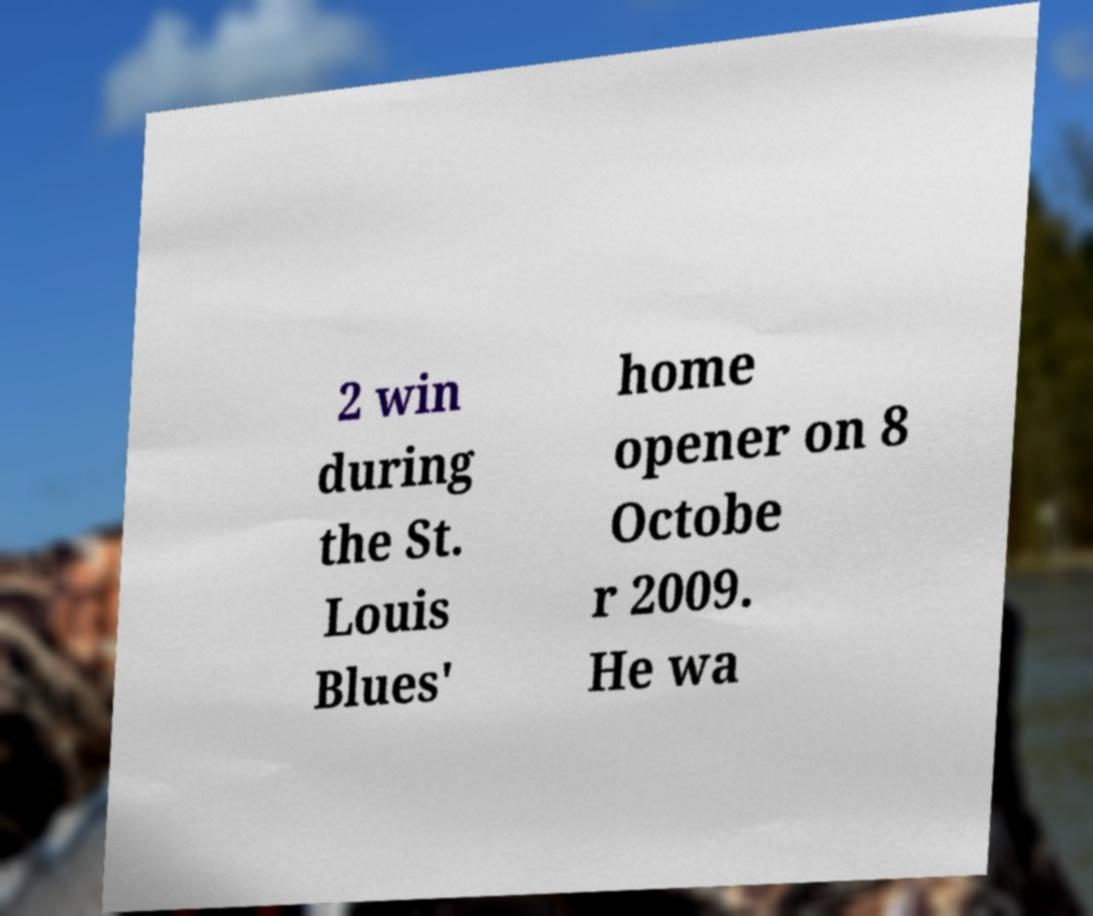For documentation purposes, I need the text within this image transcribed. Could you provide that? 2 win during the St. Louis Blues' home opener on 8 Octobe r 2009. He wa 